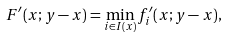Convert formula to latex. <formula><loc_0><loc_0><loc_500><loc_500>F ^ { \prime } ( x ; y - x ) = \min _ { i \in I ( x ) } f _ { i } ^ { \prime } ( x ; y - x ) ,</formula> 